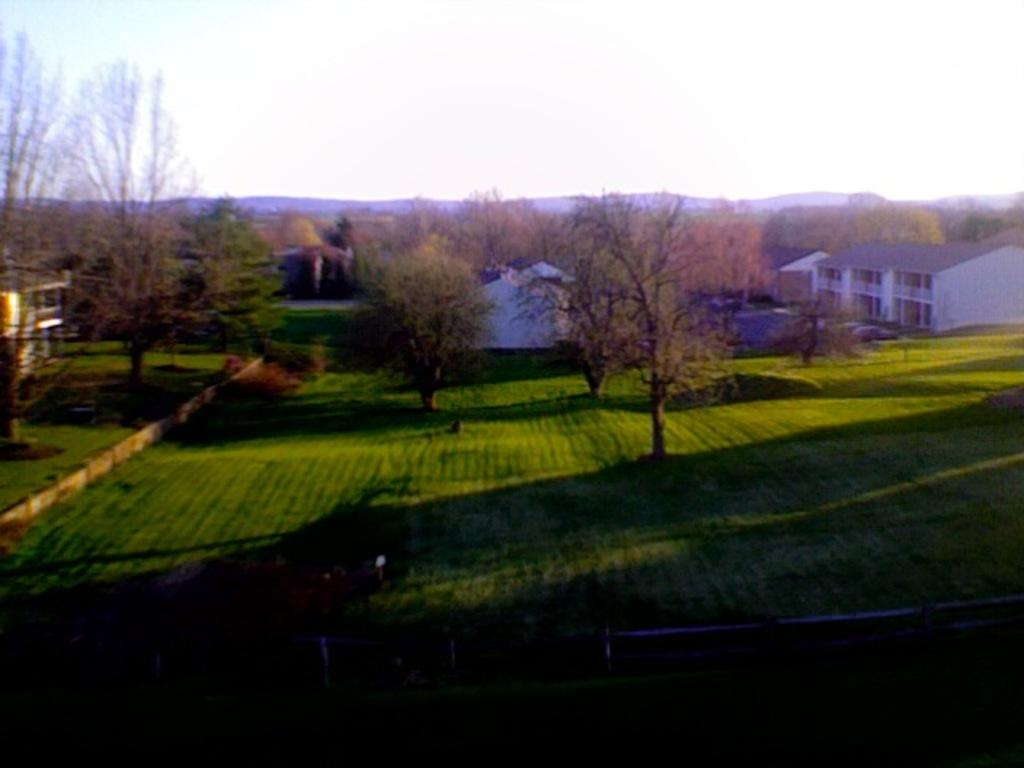What type of terrain is visible in the image? There is grassy land in the image. Are there any plants or vegetation in the image? Yes, there are trees in the image. What structures can be seen on the right side of the image? Buildings are present on the right side of the image. What color is the sky in the image? The sky is white in color. What type of apparatus is being used by the trees in the image? There is no apparatus being used by the trees in the image; they are simply standing. What part of the image is the most colorful? The question cannot be answered definitively as the image is described as having a white sky, and no other colors are mentioned in the facts. 